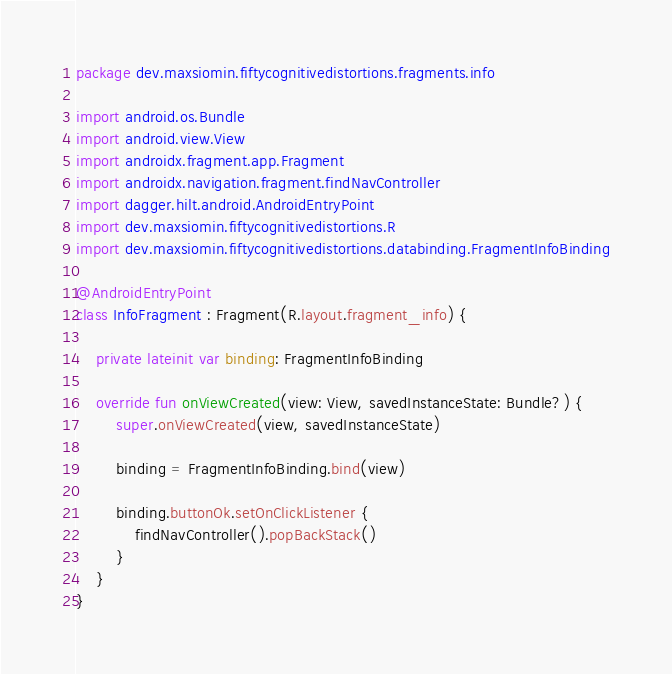<code> <loc_0><loc_0><loc_500><loc_500><_Kotlin_>package dev.maxsiomin.fiftycognitivedistortions.fragments.info

import android.os.Bundle
import android.view.View
import androidx.fragment.app.Fragment
import androidx.navigation.fragment.findNavController
import dagger.hilt.android.AndroidEntryPoint
import dev.maxsiomin.fiftycognitivedistortions.R
import dev.maxsiomin.fiftycognitivedistortions.databinding.FragmentInfoBinding

@AndroidEntryPoint
class InfoFragment : Fragment(R.layout.fragment_info) {

    private lateinit var binding: FragmentInfoBinding

    override fun onViewCreated(view: View, savedInstanceState: Bundle?) {
        super.onViewCreated(view, savedInstanceState)

        binding = FragmentInfoBinding.bind(view)

        binding.buttonOk.setOnClickListener {
            findNavController().popBackStack()
        }
    }
}
</code> 